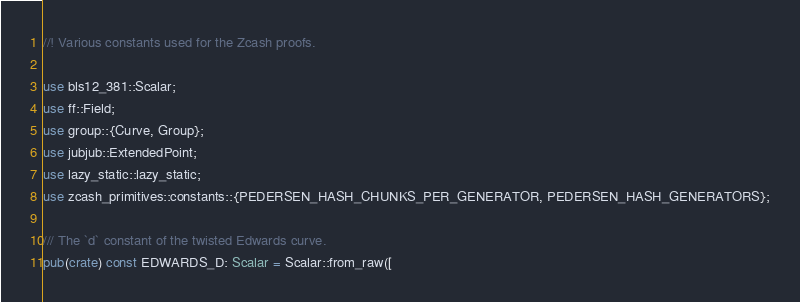Convert code to text. <code><loc_0><loc_0><loc_500><loc_500><_Rust_>//! Various constants used for the Zcash proofs.

use bls12_381::Scalar;
use ff::Field;
use group::{Curve, Group};
use jubjub::ExtendedPoint;
use lazy_static::lazy_static;
use zcash_primitives::constants::{PEDERSEN_HASH_CHUNKS_PER_GENERATOR, PEDERSEN_HASH_GENERATORS};

/// The `d` constant of the twisted Edwards curve.
pub(crate) const EDWARDS_D: Scalar = Scalar::from_raw([</code> 